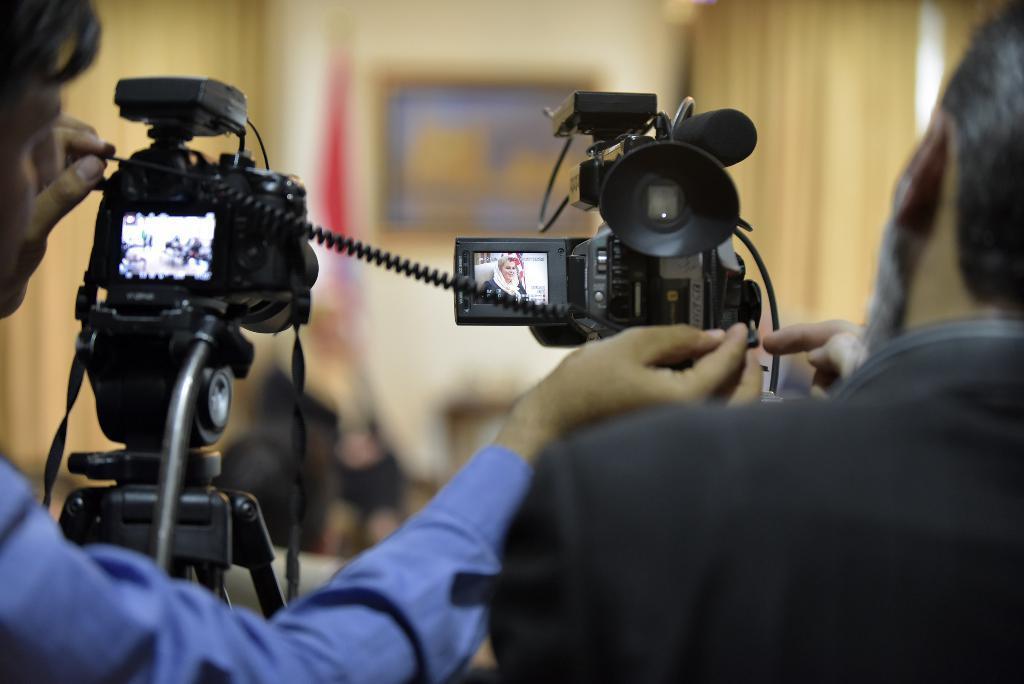Could you give a brief overview of what you see in this image? In this image we can see two persons standing, in front of them, we can see the cameras, in the background, we can see a flag and a photo frame on the wall. 